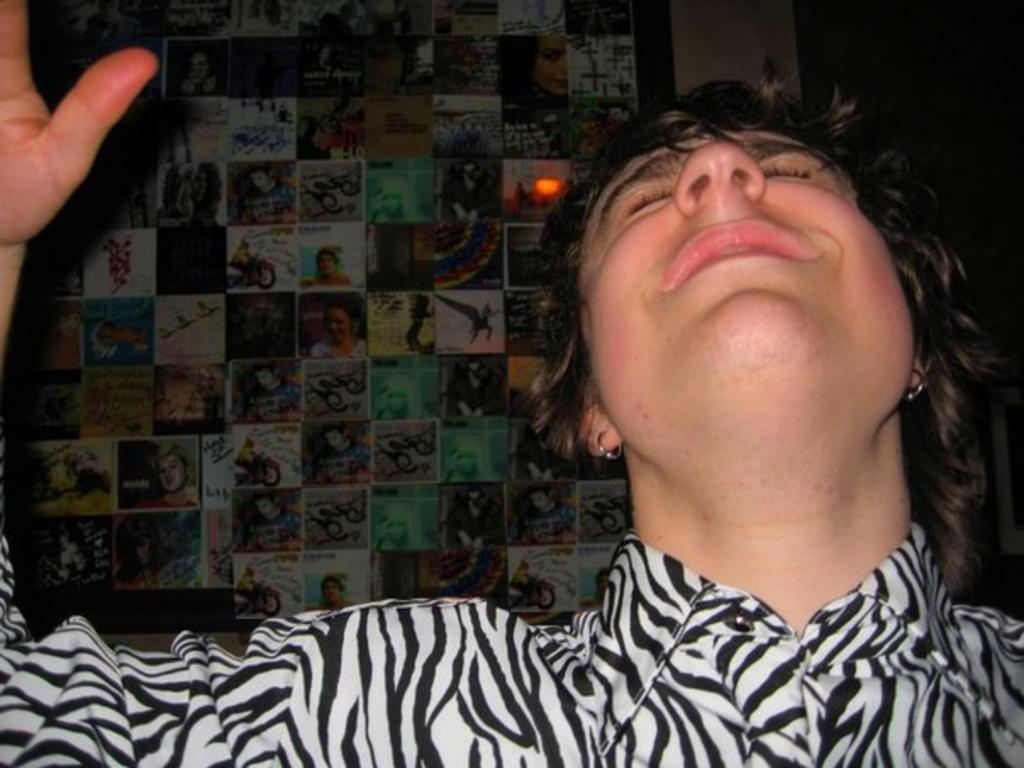Who is the main subject in the image? There is a lady in the image. Where is the lady located in the image? The lady is on the right side of the image. What can be seen in the background of the image? There is a poster in the background of the image. How does the lady appear to be feeling in the image? The lady appears to be crying. How many bikes are parked next to the lady in the image? There are no bikes present in the image. What type of coil is being used by the lady in the image? There is no coil present in the image. 